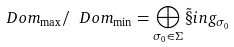<formula> <loc_0><loc_0><loc_500><loc_500>\ D o m _ { \max } / \ D o m _ { \min } = \bigoplus _ { \sigma _ { 0 } \in \Sigma } \tilde { \S } i n g _ { \sigma _ { 0 } }</formula> 